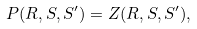<formula> <loc_0><loc_0><loc_500><loc_500>P ( R , S , S ^ { \prime } ) = Z ( R , S , S ^ { \prime } ) ,</formula> 